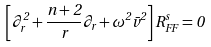<formula> <loc_0><loc_0><loc_500><loc_500>\left [ \partial _ { r } ^ { 2 } + \frac { n + 2 } { r } \partial _ { r } + \omega ^ { 2 } \bar { v } ^ { 2 } \right ] R _ { F F } ^ { s } = 0</formula> 